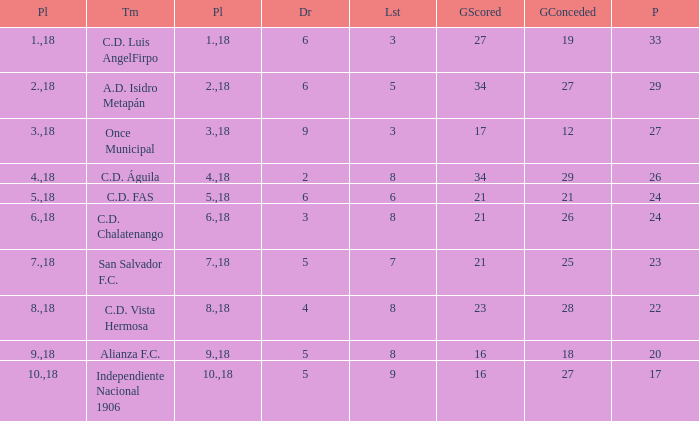How many points were in a game that had a lost of 5, greater than place 2, and 27 goals conceded? 0.0. 